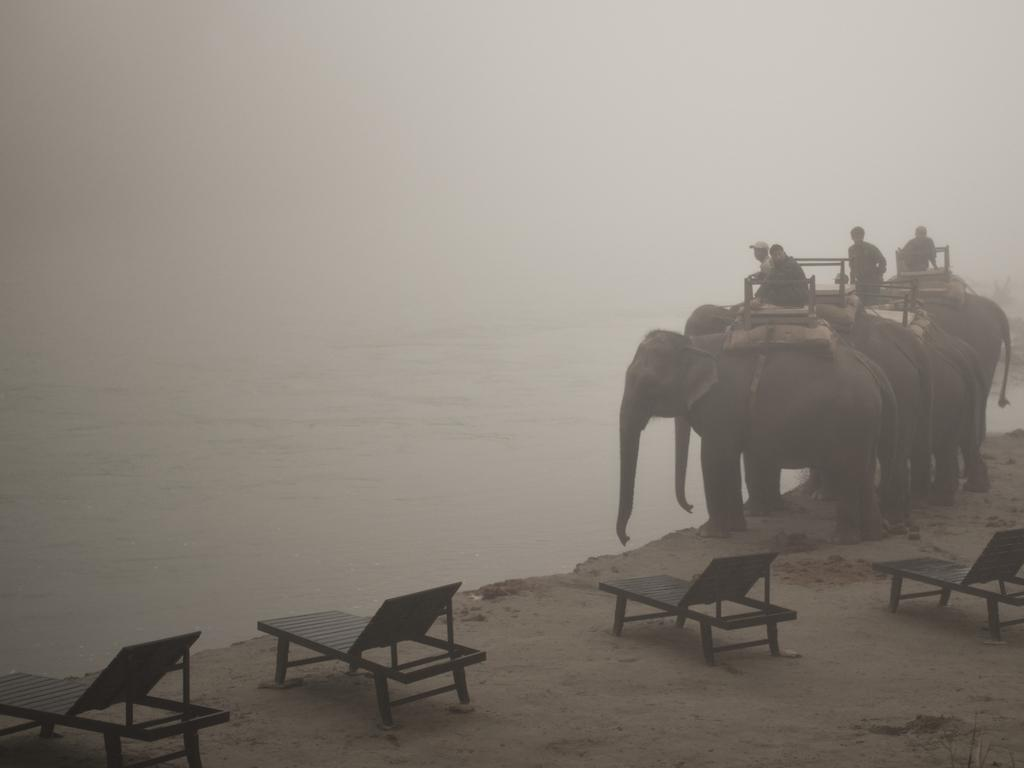What are the people doing in the image? The people are sitting on the elephants. What objects can be seen behind the elephants? There are chairs behind the elephants. What is in front of the elephants? There is water in front of the elephants. How much debt is being carried by the elephants in the image? There is no indication of debt in the image; it features people sitting on elephants with chairs and water nearby. 